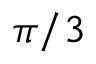<formula> <loc_0><loc_0><loc_500><loc_500>\pi / 3</formula> 